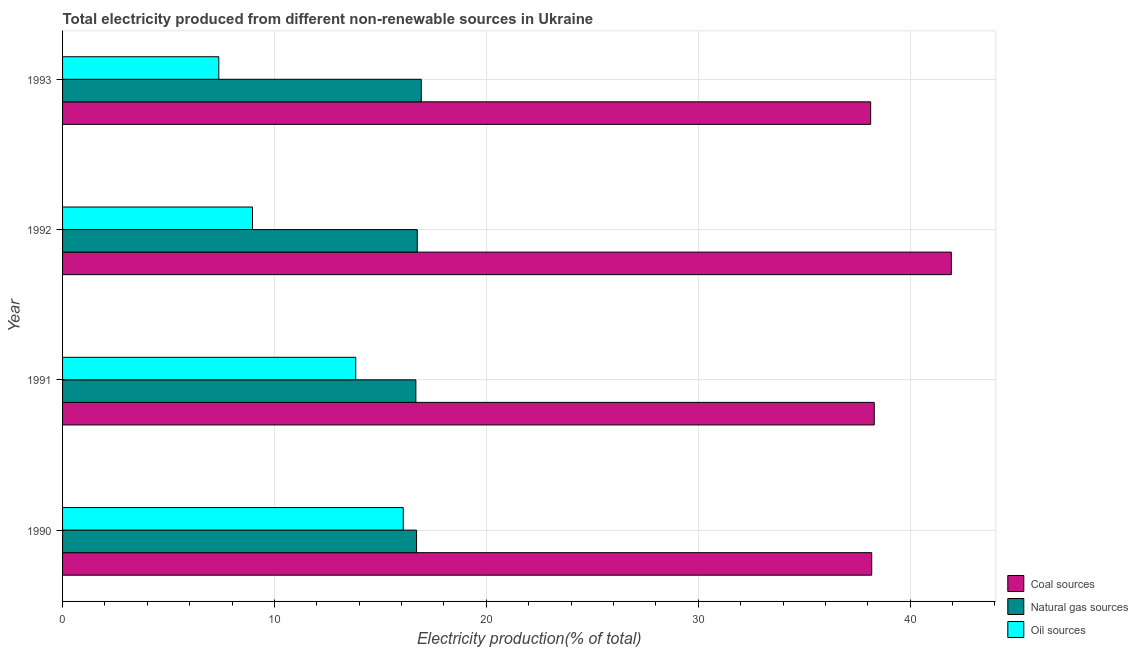How many different coloured bars are there?
Provide a succinct answer. 3. How many groups of bars are there?
Your response must be concise. 4. Are the number of bars per tick equal to the number of legend labels?
Offer a very short reply. Yes. How many bars are there on the 4th tick from the top?
Provide a succinct answer. 3. How many bars are there on the 4th tick from the bottom?
Your response must be concise. 3. What is the label of the 3rd group of bars from the top?
Provide a succinct answer. 1991. In how many cases, is the number of bars for a given year not equal to the number of legend labels?
Your response must be concise. 0. What is the percentage of electricity produced by coal in 1992?
Your answer should be very brief. 41.94. Across all years, what is the maximum percentage of electricity produced by oil sources?
Offer a terse response. 16.08. Across all years, what is the minimum percentage of electricity produced by coal?
Offer a terse response. 38.14. In which year was the percentage of electricity produced by natural gas minimum?
Your answer should be very brief. 1991. What is the total percentage of electricity produced by coal in the graph?
Offer a terse response. 156.57. What is the difference between the percentage of electricity produced by natural gas in 1990 and that in 1991?
Ensure brevity in your answer.  0.03. What is the difference between the percentage of electricity produced by oil sources in 1990 and the percentage of electricity produced by coal in 1993?
Offer a terse response. -22.06. What is the average percentage of electricity produced by oil sources per year?
Make the answer very short. 11.56. In the year 1993, what is the difference between the percentage of electricity produced by natural gas and percentage of electricity produced by oil sources?
Offer a very short reply. 9.56. In how many years, is the percentage of electricity produced by natural gas greater than 30 %?
Keep it short and to the point. 0. What is the ratio of the percentage of electricity produced by natural gas in 1991 to that in 1993?
Your answer should be compact. 0.98. Is the percentage of electricity produced by oil sources in 1992 less than that in 1993?
Give a very brief answer. No. Is the difference between the percentage of electricity produced by coal in 1990 and 1993 greater than the difference between the percentage of electricity produced by oil sources in 1990 and 1993?
Ensure brevity in your answer.  No. What is the difference between the highest and the second highest percentage of electricity produced by natural gas?
Provide a short and direct response. 0.19. What is the difference between the highest and the lowest percentage of electricity produced by coal?
Your answer should be very brief. 3.81. Is the sum of the percentage of electricity produced by natural gas in 1991 and 1993 greater than the maximum percentage of electricity produced by oil sources across all years?
Keep it short and to the point. Yes. What does the 2nd bar from the top in 1992 represents?
Offer a terse response. Natural gas sources. What does the 2nd bar from the bottom in 1992 represents?
Your answer should be compact. Natural gas sources. Is it the case that in every year, the sum of the percentage of electricity produced by coal and percentage of electricity produced by natural gas is greater than the percentage of electricity produced by oil sources?
Make the answer very short. Yes. Are all the bars in the graph horizontal?
Your answer should be compact. Yes. How many years are there in the graph?
Your response must be concise. 4. Are the values on the major ticks of X-axis written in scientific E-notation?
Your response must be concise. No. Does the graph contain any zero values?
Make the answer very short. No. Does the graph contain grids?
Offer a terse response. Yes. What is the title of the graph?
Your response must be concise. Total electricity produced from different non-renewable sources in Ukraine. Does "Labor Market" appear as one of the legend labels in the graph?
Your answer should be compact. No. What is the label or title of the X-axis?
Provide a short and direct response. Electricity production(% of total). What is the Electricity production(% of total) in Coal sources in 1990?
Your answer should be compact. 38.19. What is the Electricity production(% of total) in Natural gas sources in 1990?
Your answer should be very brief. 16.71. What is the Electricity production(% of total) in Oil sources in 1990?
Your answer should be very brief. 16.08. What is the Electricity production(% of total) in Coal sources in 1991?
Provide a short and direct response. 38.31. What is the Electricity production(% of total) in Natural gas sources in 1991?
Give a very brief answer. 16.67. What is the Electricity production(% of total) of Oil sources in 1991?
Your answer should be very brief. 13.84. What is the Electricity production(% of total) in Coal sources in 1992?
Give a very brief answer. 41.94. What is the Electricity production(% of total) of Natural gas sources in 1992?
Your response must be concise. 16.74. What is the Electricity production(% of total) of Oil sources in 1992?
Offer a terse response. 8.96. What is the Electricity production(% of total) of Coal sources in 1993?
Your answer should be very brief. 38.14. What is the Electricity production(% of total) in Natural gas sources in 1993?
Your answer should be compact. 16.93. What is the Electricity production(% of total) of Oil sources in 1993?
Provide a short and direct response. 7.37. Across all years, what is the maximum Electricity production(% of total) of Coal sources?
Provide a succinct answer. 41.94. Across all years, what is the maximum Electricity production(% of total) of Natural gas sources?
Provide a succinct answer. 16.93. Across all years, what is the maximum Electricity production(% of total) in Oil sources?
Ensure brevity in your answer.  16.08. Across all years, what is the minimum Electricity production(% of total) in Coal sources?
Keep it short and to the point. 38.14. Across all years, what is the minimum Electricity production(% of total) in Natural gas sources?
Provide a short and direct response. 16.67. Across all years, what is the minimum Electricity production(% of total) of Oil sources?
Keep it short and to the point. 7.37. What is the total Electricity production(% of total) of Coal sources in the graph?
Your response must be concise. 156.57. What is the total Electricity production(% of total) of Natural gas sources in the graph?
Ensure brevity in your answer.  67.05. What is the total Electricity production(% of total) in Oil sources in the graph?
Provide a short and direct response. 46.25. What is the difference between the Electricity production(% of total) of Coal sources in 1990 and that in 1991?
Provide a short and direct response. -0.12. What is the difference between the Electricity production(% of total) of Natural gas sources in 1990 and that in 1991?
Ensure brevity in your answer.  0.03. What is the difference between the Electricity production(% of total) of Oil sources in 1990 and that in 1991?
Give a very brief answer. 2.24. What is the difference between the Electricity production(% of total) in Coal sources in 1990 and that in 1992?
Offer a terse response. -3.76. What is the difference between the Electricity production(% of total) in Natural gas sources in 1990 and that in 1992?
Give a very brief answer. -0.03. What is the difference between the Electricity production(% of total) in Oil sources in 1990 and that in 1992?
Provide a succinct answer. 7.11. What is the difference between the Electricity production(% of total) in Coal sources in 1990 and that in 1993?
Make the answer very short. 0.05. What is the difference between the Electricity production(% of total) in Natural gas sources in 1990 and that in 1993?
Offer a terse response. -0.22. What is the difference between the Electricity production(% of total) of Oil sources in 1990 and that in 1993?
Ensure brevity in your answer.  8.7. What is the difference between the Electricity production(% of total) in Coal sources in 1991 and that in 1992?
Make the answer very short. -3.64. What is the difference between the Electricity production(% of total) of Natural gas sources in 1991 and that in 1992?
Your answer should be compact. -0.07. What is the difference between the Electricity production(% of total) of Oil sources in 1991 and that in 1992?
Offer a terse response. 4.87. What is the difference between the Electricity production(% of total) of Coal sources in 1991 and that in 1993?
Provide a succinct answer. 0.17. What is the difference between the Electricity production(% of total) in Natural gas sources in 1991 and that in 1993?
Make the answer very short. -0.26. What is the difference between the Electricity production(% of total) in Oil sources in 1991 and that in 1993?
Your response must be concise. 6.46. What is the difference between the Electricity production(% of total) in Coal sources in 1992 and that in 1993?
Offer a terse response. 3.81. What is the difference between the Electricity production(% of total) of Natural gas sources in 1992 and that in 1993?
Provide a succinct answer. -0.19. What is the difference between the Electricity production(% of total) of Oil sources in 1992 and that in 1993?
Your answer should be very brief. 1.59. What is the difference between the Electricity production(% of total) in Coal sources in 1990 and the Electricity production(% of total) in Natural gas sources in 1991?
Offer a terse response. 21.51. What is the difference between the Electricity production(% of total) of Coal sources in 1990 and the Electricity production(% of total) of Oil sources in 1991?
Your answer should be compact. 24.35. What is the difference between the Electricity production(% of total) of Natural gas sources in 1990 and the Electricity production(% of total) of Oil sources in 1991?
Provide a short and direct response. 2.87. What is the difference between the Electricity production(% of total) of Coal sources in 1990 and the Electricity production(% of total) of Natural gas sources in 1992?
Ensure brevity in your answer.  21.45. What is the difference between the Electricity production(% of total) in Coal sources in 1990 and the Electricity production(% of total) in Oil sources in 1992?
Provide a short and direct response. 29.22. What is the difference between the Electricity production(% of total) of Natural gas sources in 1990 and the Electricity production(% of total) of Oil sources in 1992?
Offer a very short reply. 7.74. What is the difference between the Electricity production(% of total) in Coal sources in 1990 and the Electricity production(% of total) in Natural gas sources in 1993?
Ensure brevity in your answer.  21.26. What is the difference between the Electricity production(% of total) in Coal sources in 1990 and the Electricity production(% of total) in Oil sources in 1993?
Offer a terse response. 30.81. What is the difference between the Electricity production(% of total) in Natural gas sources in 1990 and the Electricity production(% of total) in Oil sources in 1993?
Provide a succinct answer. 9.33. What is the difference between the Electricity production(% of total) in Coal sources in 1991 and the Electricity production(% of total) in Natural gas sources in 1992?
Offer a terse response. 21.57. What is the difference between the Electricity production(% of total) of Coal sources in 1991 and the Electricity production(% of total) of Oil sources in 1992?
Make the answer very short. 29.34. What is the difference between the Electricity production(% of total) of Natural gas sources in 1991 and the Electricity production(% of total) of Oil sources in 1992?
Ensure brevity in your answer.  7.71. What is the difference between the Electricity production(% of total) in Coal sources in 1991 and the Electricity production(% of total) in Natural gas sources in 1993?
Keep it short and to the point. 21.38. What is the difference between the Electricity production(% of total) in Coal sources in 1991 and the Electricity production(% of total) in Oil sources in 1993?
Offer a terse response. 30.93. What is the difference between the Electricity production(% of total) in Natural gas sources in 1991 and the Electricity production(% of total) in Oil sources in 1993?
Offer a terse response. 9.3. What is the difference between the Electricity production(% of total) of Coal sources in 1992 and the Electricity production(% of total) of Natural gas sources in 1993?
Ensure brevity in your answer.  25.01. What is the difference between the Electricity production(% of total) in Coal sources in 1992 and the Electricity production(% of total) in Oil sources in 1993?
Your response must be concise. 34.57. What is the difference between the Electricity production(% of total) in Natural gas sources in 1992 and the Electricity production(% of total) in Oil sources in 1993?
Ensure brevity in your answer.  9.37. What is the average Electricity production(% of total) of Coal sources per year?
Your answer should be compact. 39.14. What is the average Electricity production(% of total) in Natural gas sources per year?
Provide a succinct answer. 16.76. What is the average Electricity production(% of total) of Oil sources per year?
Offer a terse response. 11.56. In the year 1990, what is the difference between the Electricity production(% of total) of Coal sources and Electricity production(% of total) of Natural gas sources?
Provide a succinct answer. 21.48. In the year 1990, what is the difference between the Electricity production(% of total) of Coal sources and Electricity production(% of total) of Oil sources?
Provide a succinct answer. 22.11. In the year 1990, what is the difference between the Electricity production(% of total) of Natural gas sources and Electricity production(% of total) of Oil sources?
Your response must be concise. 0.63. In the year 1991, what is the difference between the Electricity production(% of total) in Coal sources and Electricity production(% of total) in Natural gas sources?
Make the answer very short. 21.63. In the year 1991, what is the difference between the Electricity production(% of total) in Coal sources and Electricity production(% of total) in Oil sources?
Ensure brevity in your answer.  24.47. In the year 1991, what is the difference between the Electricity production(% of total) in Natural gas sources and Electricity production(% of total) in Oil sources?
Make the answer very short. 2.84. In the year 1992, what is the difference between the Electricity production(% of total) of Coal sources and Electricity production(% of total) of Natural gas sources?
Make the answer very short. 25.2. In the year 1992, what is the difference between the Electricity production(% of total) of Coal sources and Electricity production(% of total) of Oil sources?
Keep it short and to the point. 32.98. In the year 1992, what is the difference between the Electricity production(% of total) of Natural gas sources and Electricity production(% of total) of Oil sources?
Keep it short and to the point. 7.77. In the year 1993, what is the difference between the Electricity production(% of total) in Coal sources and Electricity production(% of total) in Natural gas sources?
Keep it short and to the point. 21.21. In the year 1993, what is the difference between the Electricity production(% of total) in Coal sources and Electricity production(% of total) in Oil sources?
Provide a short and direct response. 30.76. In the year 1993, what is the difference between the Electricity production(% of total) of Natural gas sources and Electricity production(% of total) of Oil sources?
Provide a succinct answer. 9.56. What is the ratio of the Electricity production(% of total) of Oil sources in 1990 to that in 1991?
Give a very brief answer. 1.16. What is the ratio of the Electricity production(% of total) of Coal sources in 1990 to that in 1992?
Your answer should be compact. 0.91. What is the ratio of the Electricity production(% of total) in Oil sources in 1990 to that in 1992?
Offer a very short reply. 1.79. What is the ratio of the Electricity production(% of total) in Oil sources in 1990 to that in 1993?
Provide a short and direct response. 2.18. What is the ratio of the Electricity production(% of total) of Coal sources in 1991 to that in 1992?
Offer a terse response. 0.91. What is the ratio of the Electricity production(% of total) in Oil sources in 1991 to that in 1992?
Ensure brevity in your answer.  1.54. What is the ratio of the Electricity production(% of total) in Coal sources in 1991 to that in 1993?
Provide a succinct answer. 1. What is the ratio of the Electricity production(% of total) in Natural gas sources in 1991 to that in 1993?
Your answer should be compact. 0.98. What is the ratio of the Electricity production(% of total) of Oil sources in 1991 to that in 1993?
Offer a terse response. 1.88. What is the ratio of the Electricity production(% of total) in Coal sources in 1992 to that in 1993?
Provide a succinct answer. 1.1. What is the ratio of the Electricity production(% of total) in Oil sources in 1992 to that in 1993?
Give a very brief answer. 1.22. What is the difference between the highest and the second highest Electricity production(% of total) of Coal sources?
Offer a very short reply. 3.64. What is the difference between the highest and the second highest Electricity production(% of total) of Natural gas sources?
Offer a very short reply. 0.19. What is the difference between the highest and the second highest Electricity production(% of total) of Oil sources?
Give a very brief answer. 2.24. What is the difference between the highest and the lowest Electricity production(% of total) in Coal sources?
Your answer should be very brief. 3.81. What is the difference between the highest and the lowest Electricity production(% of total) of Natural gas sources?
Make the answer very short. 0.26. What is the difference between the highest and the lowest Electricity production(% of total) of Oil sources?
Your response must be concise. 8.7. 